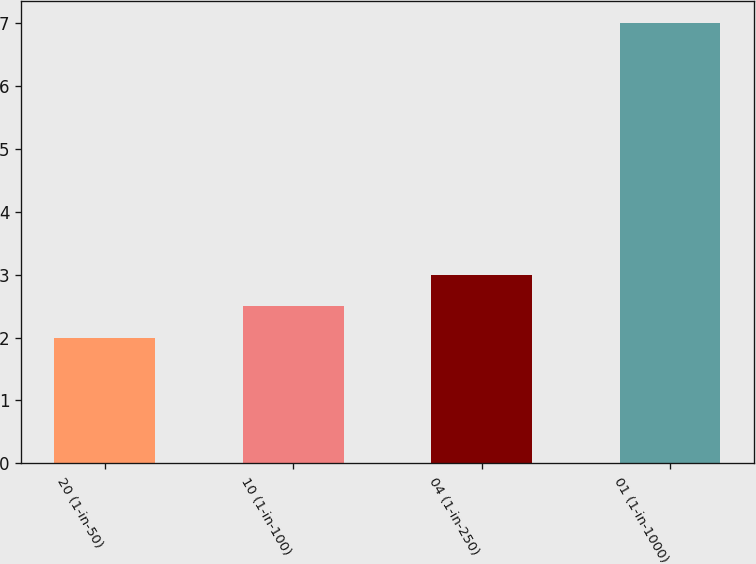Convert chart to OTSL. <chart><loc_0><loc_0><loc_500><loc_500><bar_chart><fcel>20 (1-in-50)<fcel>10 (1-in-100)<fcel>04 (1-in-250)<fcel>01 (1-in-1000)<nl><fcel>2<fcel>2.5<fcel>3<fcel>7<nl></chart> 